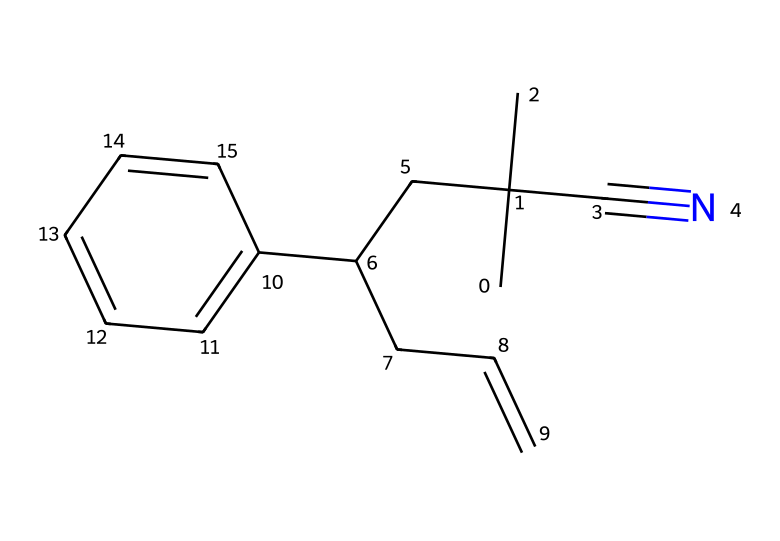What is the main functional group present in this chemical? The chemical structure contains a cyano group (C#N) which is a characteristic functional group with a carbon triple bonded to nitrogen.
Answer: cyano How many carbon atoms are in this molecule? By examining the structure, there are a total of 12 carbon atoms (each "C" in the SMILES contributes a carbon).
Answer: 12 What type of polymer does acrylonitrile butadiene styrene (ABS) represent? ABS is classified as a thermoplastic polymer, known for its toughness and impact resistance.
Answer: thermoplastic How many double bonds are present in the structure? The visual assessment shows one double bond in the chain, specifically in the CC=C part of the structure.
Answer: 1 What type of bonds primarily characterize this polymer? The polymer is characterized by covalent bonds, which connect the carbon atoms and the cyano group within the structure.
Answer: covalent What is the significance of the butadiene component in ABS? Butadiene enhances the elasticity and impact resistance of the polymer, making it suitable for applications like computer mouse casings.
Answer: elasticity Which aromatic ring is part of this chemical structure? The benzene ring, represented by "c1ccccc1" in the SMILES notation, is the aromatic portion contributing to the chemical's properties.
Answer: benzene 